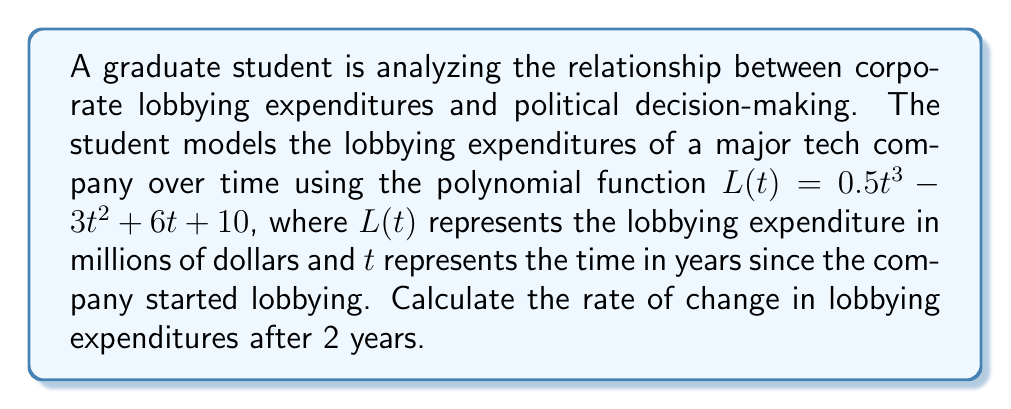Can you answer this question? To find the rate of change in lobbying expenditures, we need to calculate the derivative of the given function $L(t)$ and then evaluate it at $t=2$.

Step 1: Calculate the derivative of $L(t)$
$$L(t) = 0.5t^3 - 3t^2 + 6t + 10$$
$$L'(t) = 1.5t^2 - 6t + 6$$

Step 2: Evaluate $L'(t)$ at $t=2$
$$L'(2) = 1.5(2)^2 - 6(2) + 6$$
$$L'(2) = 1.5(4) - 12 + 6$$
$$L'(2) = 6 - 12 + 6$$
$$L'(2) = 0$$

The rate of change in lobbying expenditures after 2 years is 0 million dollars per year.
Answer: $0$ million dollars per year 